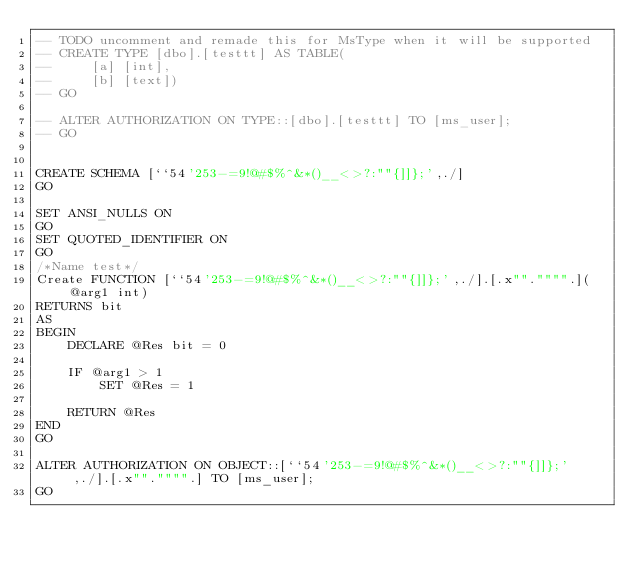<code> <loc_0><loc_0><loc_500><loc_500><_SQL_>-- TODO uncomment and remade this for MsType when it will be supported
-- CREATE TYPE [dbo].[testtt] AS TABLE( 
--     [a] [int],
--     [b] [text])  
-- GO

-- ALTER AUTHORIZATION ON TYPE::[dbo].[testtt] TO [ms_user];    
-- GO


CREATE SCHEMA [``54'253-=9!@#$%^&*()__<>?:""{]]};',./]
GO

SET ANSI_NULLS ON
GO
SET QUOTED_IDENTIFIER ON
GO
/*Name test*/
Create FUNCTION [``54'253-=9!@#$%^&*()__<>?:""{]]};',./].[.x""."""".](@arg1 int)
RETURNS bit
AS
BEGIN
    DECLARE @Res bit = 0

    IF @arg1 > 1
        SET @Res = 1

    RETURN @Res
END
GO

ALTER AUTHORIZATION ON OBJECT::[``54'253-=9!@#$%^&*()__<>?:""{]]};',./].[.x""."""".] TO [ms_user];    
GO
</code> 